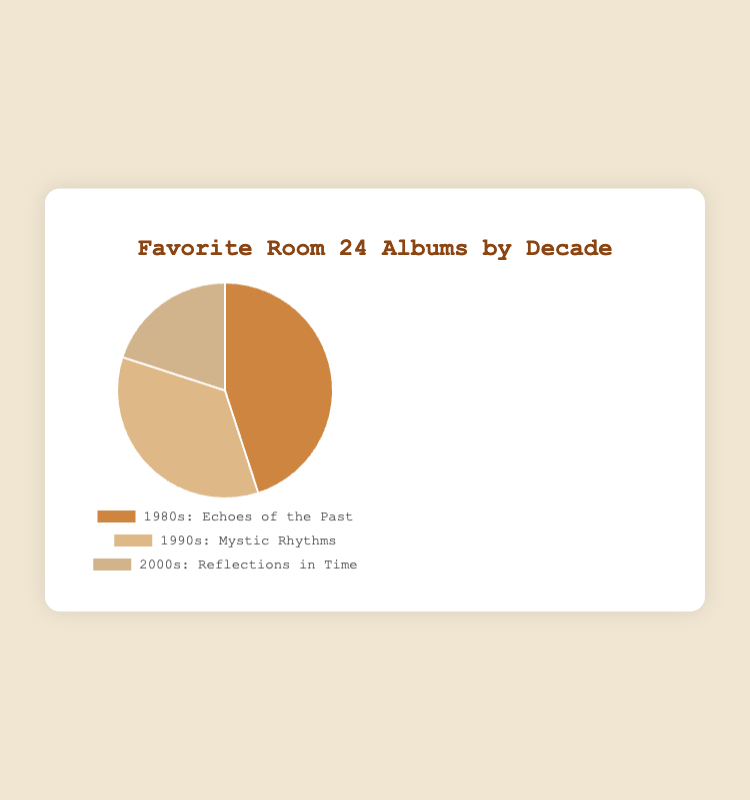What percentage of people prefer the album from the 1990s? The 1990s album "Mystic Rhythms" is shown as 35% of the total pie chart.
Answer: 35% Which decade has the lowest preference for Room 24 albums? Look for the smallest section of the pie chart, which is "2000s: Reflections in Time" at 20%.
Answer: 2000s How much more popular is the 1980s album compared to the 2000s album? The 1980s album "Echoes of the Past" has 45%, and the 2000s album "Reflections in Time" has 20%. Subtract 20% from 45% to find the difference.
Answer: 25% Compare the preferences between the 1980s and the 1990s albums. Which one is preferred more and by what percentage? The 1980s album is preferred by 45% and the 1990s album by 35%. Thus, the 1980s album is more popular by 45% - 35% = 10%.
Answer: 1980s, 10% What is the combined preference percentage for the albums from the 1990s and 2000s? Add the percentages for the 1990s album "Mystic Rhythms" (35%) and the 2000s album "Reflections in Time" (20%), resulting in 35% + 20% = 55%.
Answer: 55% Which color represents the 2000s decade in the chart? The section labeled "2000s: Reflections in Time" is shown in a light tan color.
Answer: Light tan Is the percentage of preference for the 1980s album greater than the combined preference for the 1990s and 2000s albums? The 1980s album is preferred by 45%. The combined percentage for 1990s and 2000s is 35% + 20% = 55%. Thus, the percentage for 1980s is less.
Answer: No What is the average preference percentage for the three decades represented? Add up the percentages (45% + 35% + 20%) to get 100%. Then, divide by the number of decades (3) to get the average: 100% / 3 = 33.33%.
Answer: 33.33% 